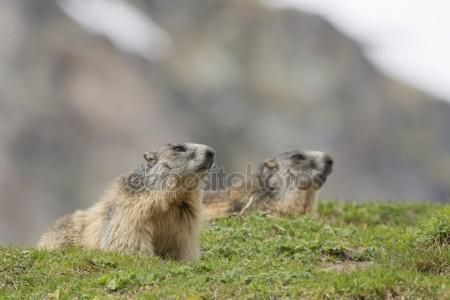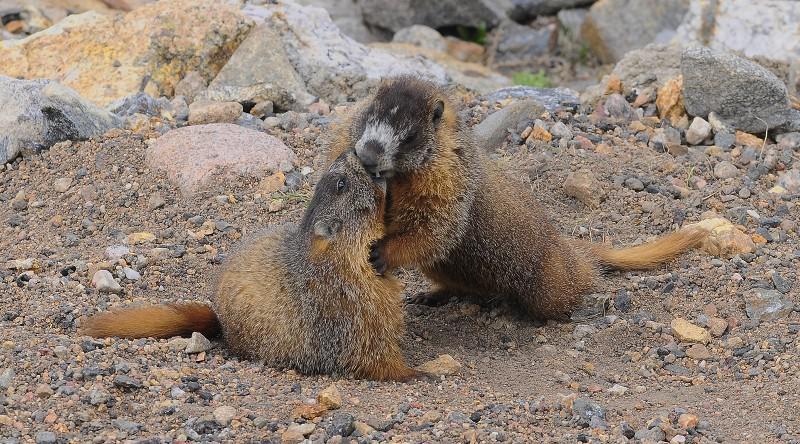The first image is the image on the left, the second image is the image on the right. Considering the images on both sides, is "Each image contains two animals, and at least two of the animals are touching." valid? Answer yes or no. Yes. 